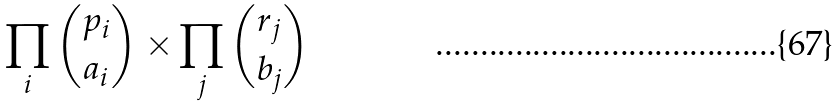Convert formula to latex. <formula><loc_0><loc_0><loc_500><loc_500>\prod _ { i } \binom { p _ { i } } { a _ { i } } \times \prod _ { j } \binom { r _ { j } } { b _ { j } }</formula> 